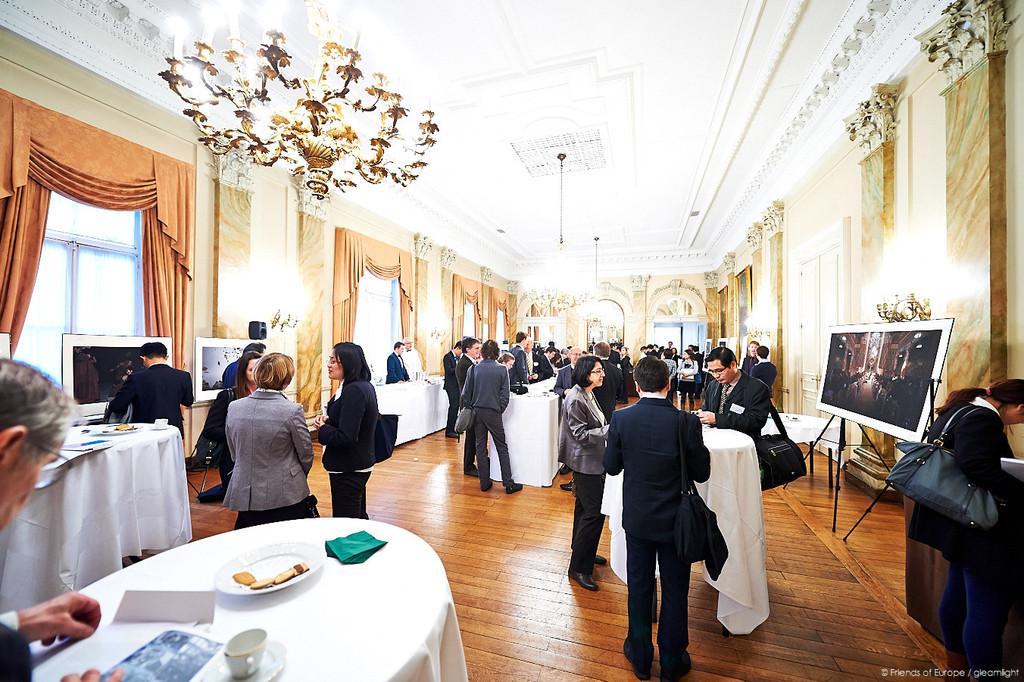How would you summarize this image in a sentence or two? In this image, there are group of people standing in front of the table where wall paintings are kept. A roof top is white on color on which chandelier is hanged. On both side of the image, there are windows on which curtains are there. This image is taken inside a hall. 